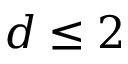Convert formula to latex. <formula><loc_0><loc_0><loc_500><loc_500>d \leq 2</formula> 